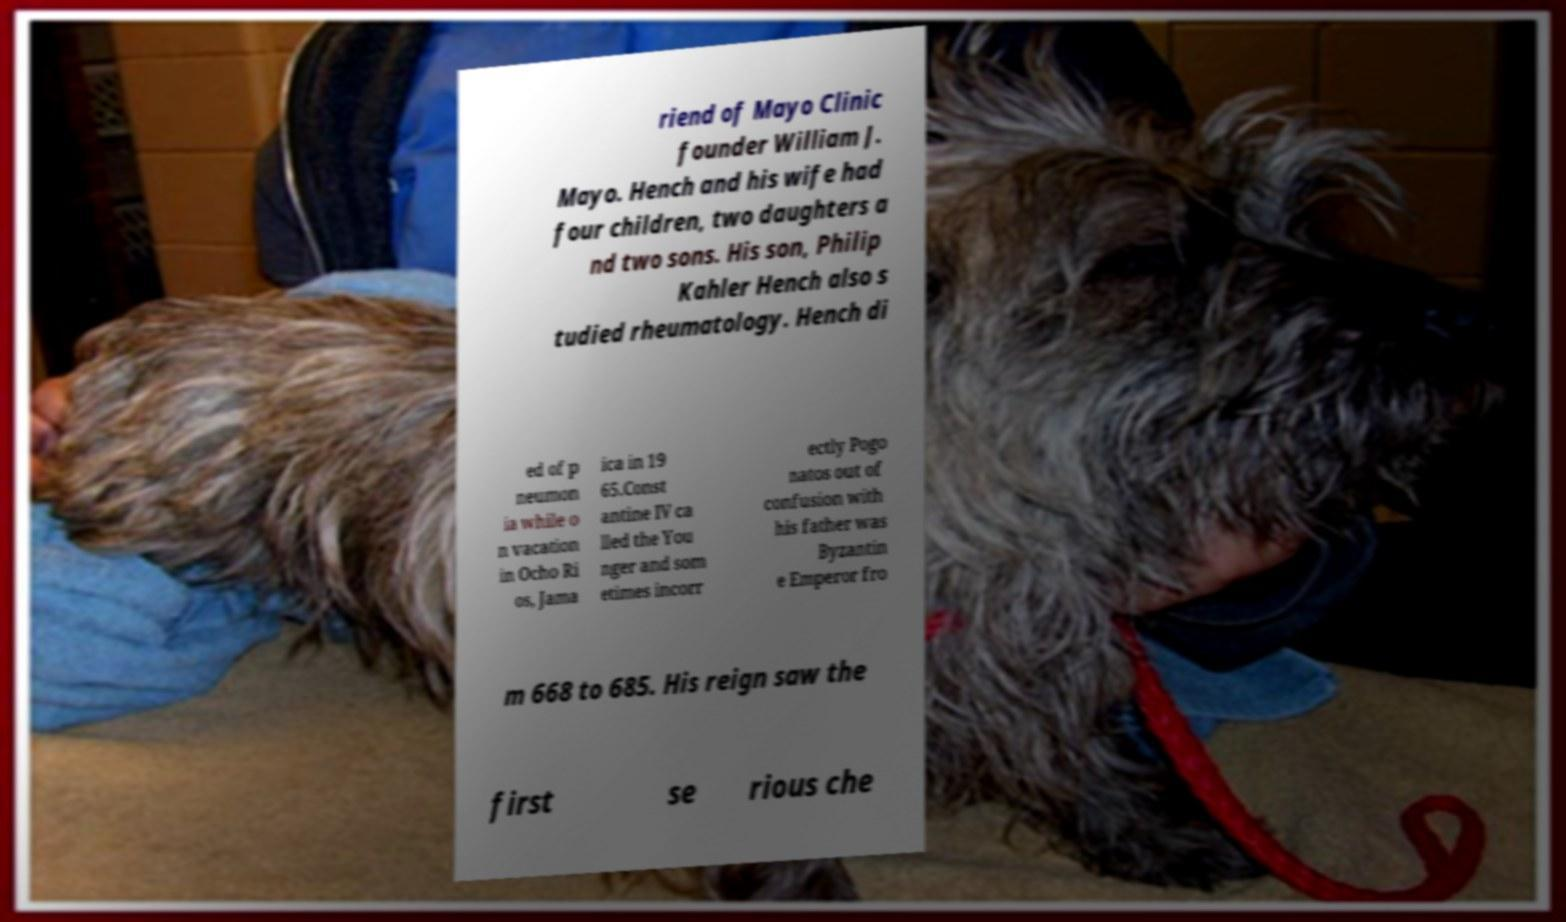Please identify and transcribe the text found in this image. riend of Mayo Clinic founder William J. Mayo. Hench and his wife had four children, two daughters a nd two sons. His son, Philip Kahler Hench also s tudied rheumatology. Hench di ed of p neumon ia while o n vacation in Ocho Ri os, Jama ica in 19 65.Const antine IV ca lled the You nger and som etimes incorr ectly Pogo natos out of confusion with his father was Byzantin e Emperor fro m 668 to 685. His reign saw the first se rious che 